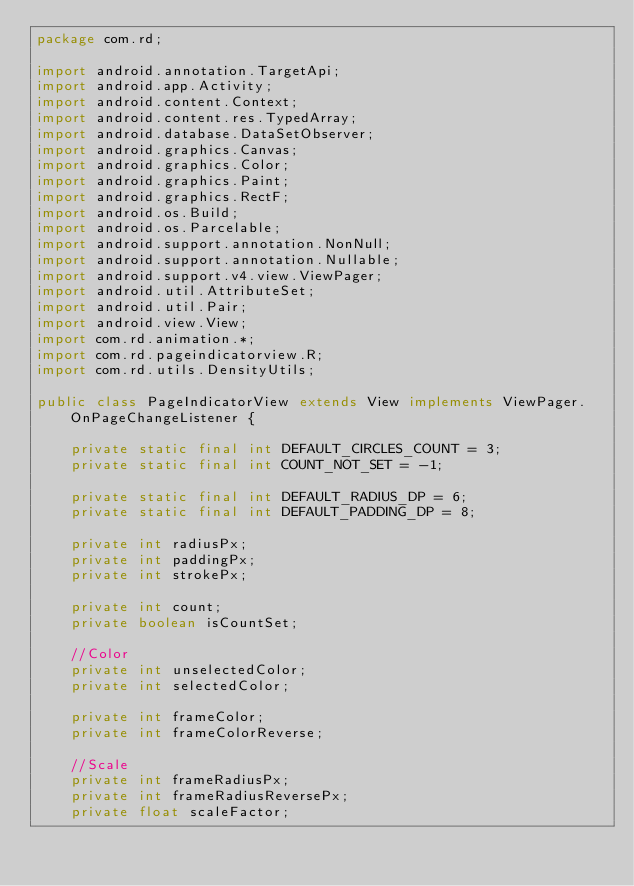<code> <loc_0><loc_0><loc_500><loc_500><_Java_>package com.rd;

import android.annotation.TargetApi;
import android.app.Activity;
import android.content.Context;
import android.content.res.TypedArray;
import android.database.DataSetObserver;
import android.graphics.Canvas;
import android.graphics.Color;
import android.graphics.Paint;
import android.graphics.RectF;
import android.os.Build;
import android.os.Parcelable;
import android.support.annotation.NonNull;
import android.support.annotation.Nullable;
import android.support.v4.view.ViewPager;
import android.util.AttributeSet;
import android.util.Pair;
import android.view.View;
import com.rd.animation.*;
import com.rd.pageindicatorview.R;
import com.rd.utils.DensityUtils;

public class PageIndicatorView extends View implements ViewPager.OnPageChangeListener {

    private static final int DEFAULT_CIRCLES_COUNT = 3;
    private static final int COUNT_NOT_SET = -1;

    private static final int DEFAULT_RADIUS_DP = 6;
    private static final int DEFAULT_PADDING_DP = 8;

    private int radiusPx;
    private int paddingPx;
    private int strokePx;

    private int count;
    private boolean isCountSet;

    //Color
    private int unselectedColor;
    private int selectedColor;

    private int frameColor;
    private int frameColorReverse;

    //Scale
    private int frameRadiusPx;
    private int frameRadiusReversePx;
    private float scaleFactor;
</code> 